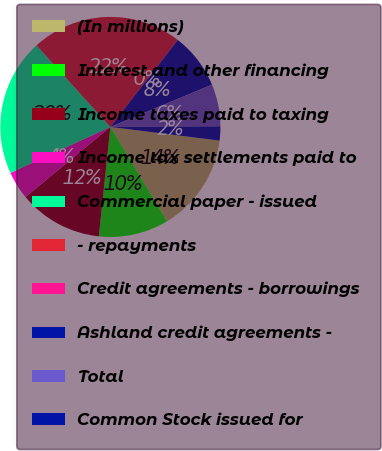<chart> <loc_0><loc_0><loc_500><loc_500><pie_chart><fcel>(In millions)<fcel>Interest and other financing<fcel>Income taxes paid to taxing<fcel>Income tax settlements paid to<fcel>Commercial paper - issued<fcel>- repayments<fcel>Credit agreements - borrowings<fcel>Ashland credit agreements -<fcel>Total<fcel>Common Stock issued for<nl><fcel>14.4%<fcel>10.29%<fcel>12.35%<fcel>4.12%<fcel>20.14%<fcel>22.2%<fcel>0.01%<fcel>8.24%<fcel>6.18%<fcel>2.07%<nl></chart> 